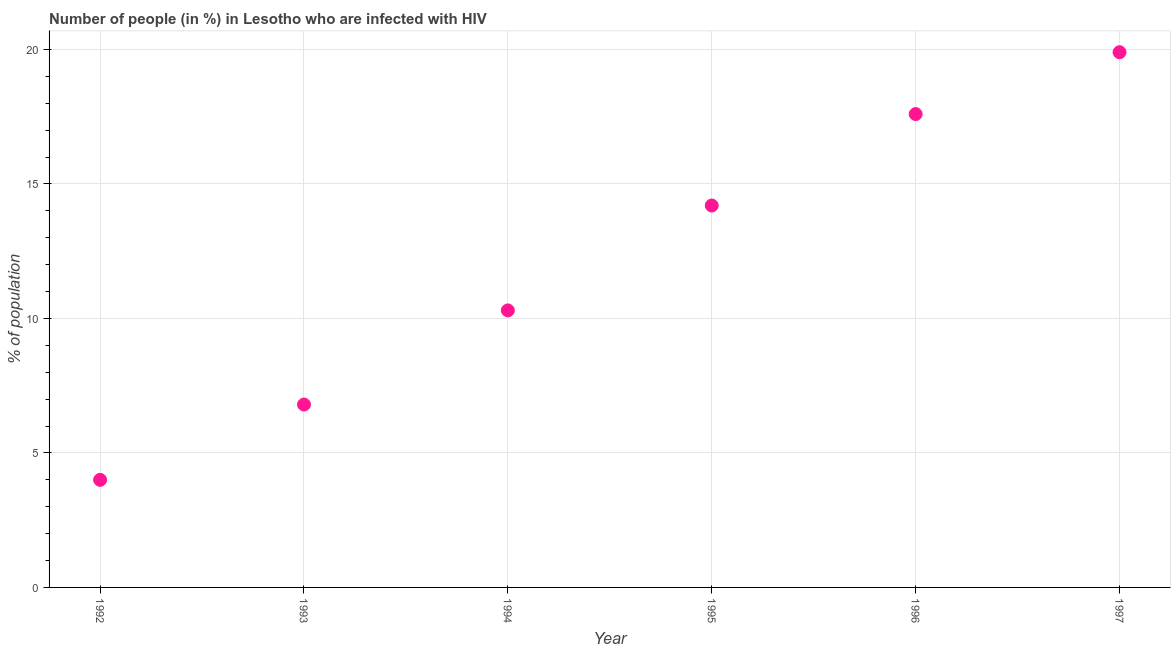What is the number of people infected with hiv in 1992?
Your answer should be compact. 4. Across all years, what is the maximum number of people infected with hiv?
Give a very brief answer. 19.9. Across all years, what is the minimum number of people infected with hiv?
Keep it short and to the point. 4. In which year was the number of people infected with hiv maximum?
Make the answer very short. 1997. In which year was the number of people infected with hiv minimum?
Provide a short and direct response. 1992. What is the sum of the number of people infected with hiv?
Ensure brevity in your answer.  72.8. What is the difference between the number of people infected with hiv in 1993 and 1997?
Provide a succinct answer. -13.1. What is the average number of people infected with hiv per year?
Keep it short and to the point. 12.13. What is the median number of people infected with hiv?
Your answer should be compact. 12.25. In how many years, is the number of people infected with hiv greater than 1 %?
Ensure brevity in your answer.  6. Do a majority of the years between 1997 and 1996 (inclusive) have number of people infected with hiv greater than 13 %?
Offer a very short reply. No. What is the ratio of the number of people infected with hiv in 1993 to that in 1995?
Provide a succinct answer. 0.48. Is the number of people infected with hiv in 1994 less than that in 1996?
Give a very brief answer. Yes. Is the difference between the number of people infected with hiv in 1995 and 1997 greater than the difference between any two years?
Your answer should be compact. No. What is the difference between the highest and the second highest number of people infected with hiv?
Ensure brevity in your answer.  2.3. Is the sum of the number of people infected with hiv in 1992 and 1996 greater than the maximum number of people infected with hiv across all years?
Keep it short and to the point. Yes. What is the difference between the highest and the lowest number of people infected with hiv?
Give a very brief answer. 15.9. How many dotlines are there?
Provide a short and direct response. 1. What is the difference between two consecutive major ticks on the Y-axis?
Give a very brief answer. 5. Does the graph contain grids?
Your answer should be compact. Yes. What is the title of the graph?
Ensure brevity in your answer.  Number of people (in %) in Lesotho who are infected with HIV. What is the label or title of the X-axis?
Give a very brief answer. Year. What is the label or title of the Y-axis?
Keep it short and to the point. % of population. What is the % of population in 1992?
Your answer should be very brief. 4. What is the % of population in 1993?
Provide a succinct answer. 6.8. What is the difference between the % of population in 1992 and 1994?
Give a very brief answer. -6.3. What is the difference between the % of population in 1992 and 1996?
Your answer should be very brief. -13.6. What is the difference between the % of population in 1992 and 1997?
Offer a very short reply. -15.9. What is the difference between the % of population in 1993 and 1995?
Provide a short and direct response. -7.4. What is the difference between the % of population in 1993 and 1996?
Your response must be concise. -10.8. What is the difference between the % of population in 1994 and 1995?
Keep it short and to the point. -3.9. What is the difference between the % of population in 1994 and 1996?
Offer a terse response. -7.3. What is the difference between the % of population in 1994 and 1997?
Your answer should be compact. -9.6. What is the difference between the % of population in 1995 and 1996?
Your answer should be very brief. -3.4. What is the difference between the % of population in 1996 and 1997?
Provide a succinct answer. -2.3. What is the ratio of the % of population in 1992 to that in 1993?
Your response must be concise. 0.59. What is the ratio of the % of population in 1992 to that in 1994?
Offer a terse response. 0.39. What is the ratio of the % of population in 1992 to that in 1995?
Provide a succinct answer. 0.28. What is the ratio of the % of population in 1992 to that in 1996?
Keep it short and to the point. 0.23. What is the ratio of the % of population in 1992 to that in 1997?
Ensure brevity in your answer.  0.2. What is the ratio of the % of population in 1993 to that in 1994?
Ensure brevity in your answer.  0.66. What is the ratio of the % of population in 1993 to that in 1995?
Keep it short and to the point. 0.48. What is the ratio of the % of population in 1993 to that in 1996?
Offer a terse response. 0.39. What is the ratio of the % of population in 1993 to that in 1997?
Keep it short and to the point. 0.34. What is the ratio of the % of population in 1994 to that in 1995?
Ensure brevity in your answer.  0.72. What is the ratio of the % of population in 1994 to that in 1996?
Keep it short and to the point. 0.58. What is the ratio of the % of population in 1994 to that in 1997?
Provide a short and direct response. 0.52. What is the ratio of the % of population in 1995 to that in 1996?
Offer a very short reply. 0.81. What is the ratio of the % of population in 1995 to that in 1997?
Make the answer very short. 0.71. What is the ratio of the % of population in 1996 to that in 1997?
Offer a very short reply. 0.88. 